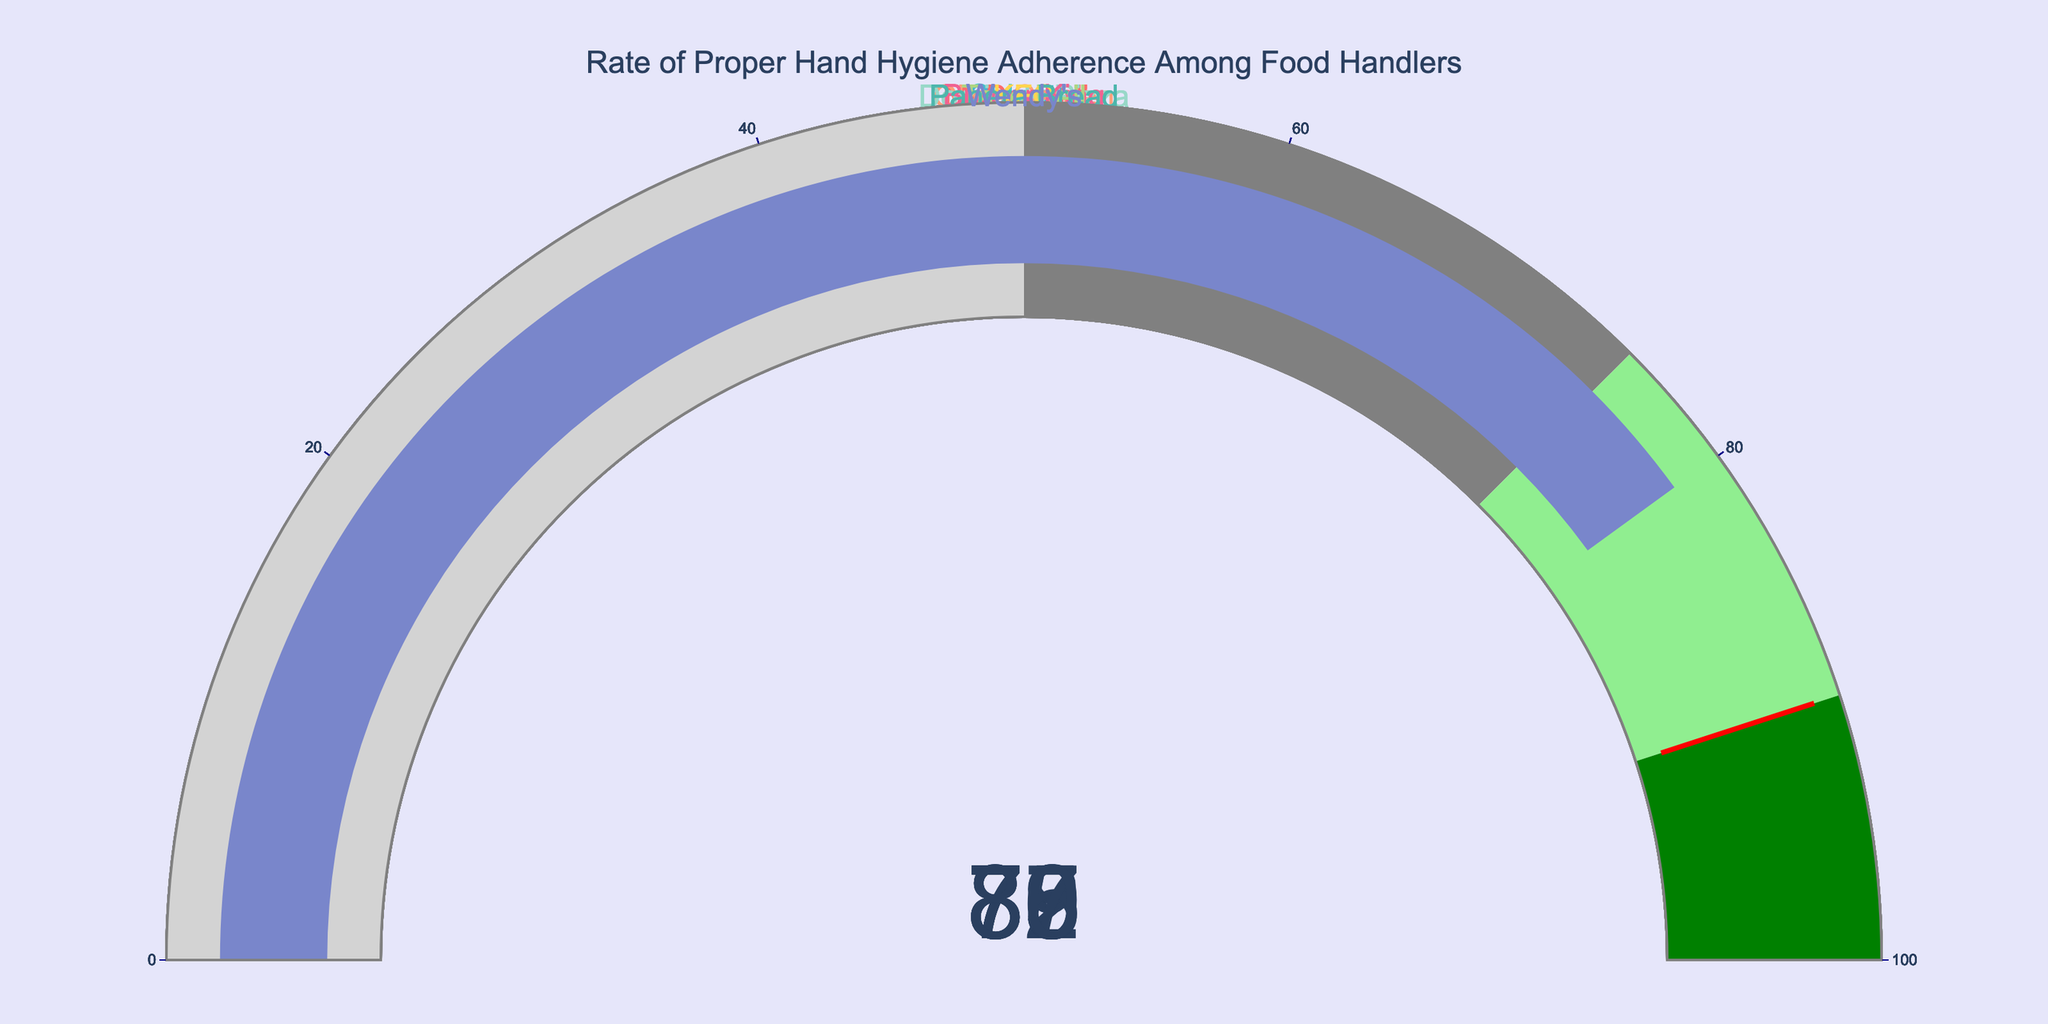What's the title of the chart? The title is usually displayed at the top of the chart. In this case, the title reads "Rate of Proper Hand Hygiene Adherence Among Food Handlers".
Answer: Rate of Proper Hand Hygiene Adherence Among Food Handlers How many restaurants are represented in the chart? To find this, count the number of gauges on the chart. Each gauge represents a different restaurant's adherence rate.
Answer: 10 Which restaurant has the highest rate of proper hand hygiene adherence? Look for the gauge with the highest numerical value. Chipotle has the highest adherence rate of 89%.
Answer: Olive Garden Which restaurant has the lowest rate of proper hand hygiene adherence? Check the gauge with the lowest numerical value to find the restaurant with the lowest adherence rate.
Answer: Burger King What is the average adherence rate among all the restaurants? Sum all the adherence rates and divide by the number of restaurants. Calculation: (78 + 82 + 85 + 89 + 76 + 73 + 79 + 75 + 87 + 80) / 10 = 804 / 10 = 80.4.
Answer: 80.4 How many restaurants have an adherence rate of 80 or higher? Count the gauges that show an adherence rate of 80 or above.
Answer: 6 Compare the adherence rate of Taco Bell and KFC. Which one is higher? Compare the values in the gauges for Taco Bell and KFC. Taco Bell has an adherence rate of 79 which is higher than KFC's rate of 75.
Answer: Taco Bell Which restaurants have adherence rates in the range of 75 to 85? Identify the gauges with values between 75 and 85, inclusive. These are McDonald's (78), Subway (82), Chipotle (85), Domino's Pizza (76), Taco Bell (79), and KFC (75).
Answer: McDonald's, Subway, Chipotle, Domino's Pizza, Taco Bell, KFC Does any restaurant have an adherence rate of 90 or above? Look at the highest gauges and see if any of them meet or exceed 90. None of the gauges indicate a rate of 90 or above.
Answer: No Which restaurant has the most similar adherence rate to Panera Bread? Identify Panera Bread's adherence rate, which is 87. Then, find the gauge with the value closest to 87. Olive Garden, with a rate of 89, is the closest.
Answer: Olive Garden 